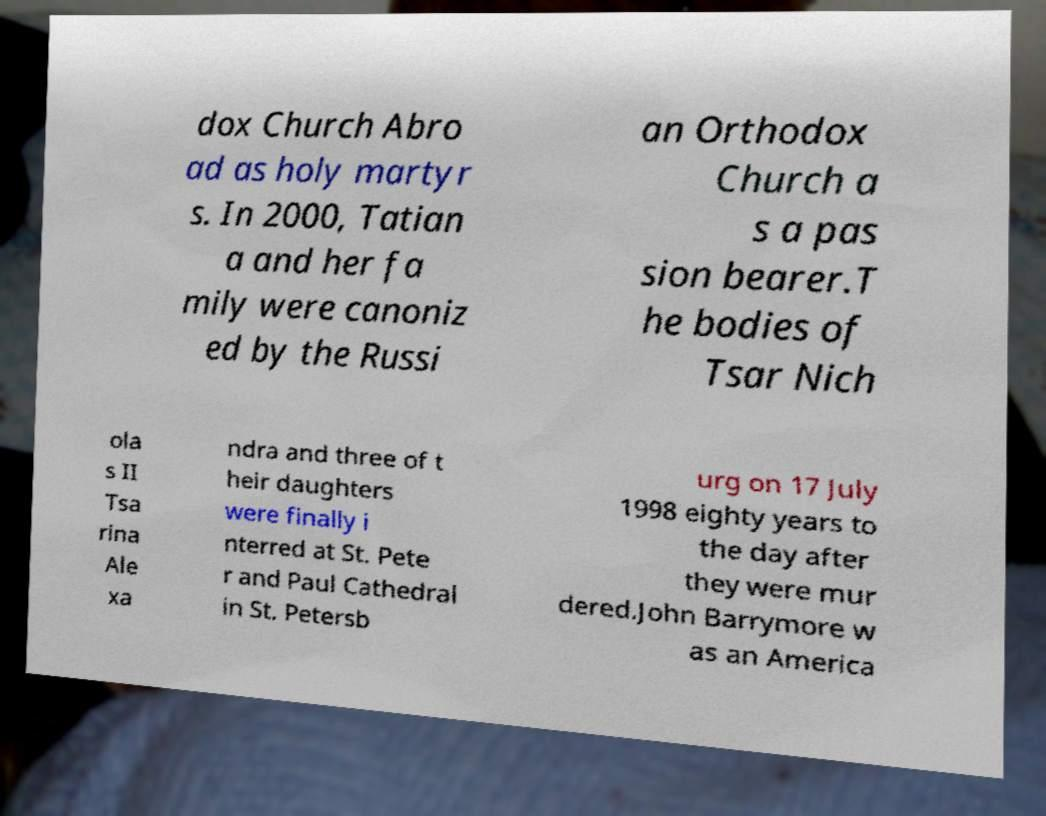For documentation purposes, I need the text within this image transcribed. Could you provide that? dox Church Abro ad as holy martyr s. In 2000, Tatian a and her fa mily were canoniz ed by the Russi an Orthodox Church a s a pas sion bearer.T he bodies of Tsar Nich ola s II Tsa rina Ale xa ndra and three of t heir daughters were finally i nterred at St. Pete r and Paul Cathedral in St. Petersb urg on 17 July 1998 eighty years to the day after they were mur dered.John Barrymore w as an America 